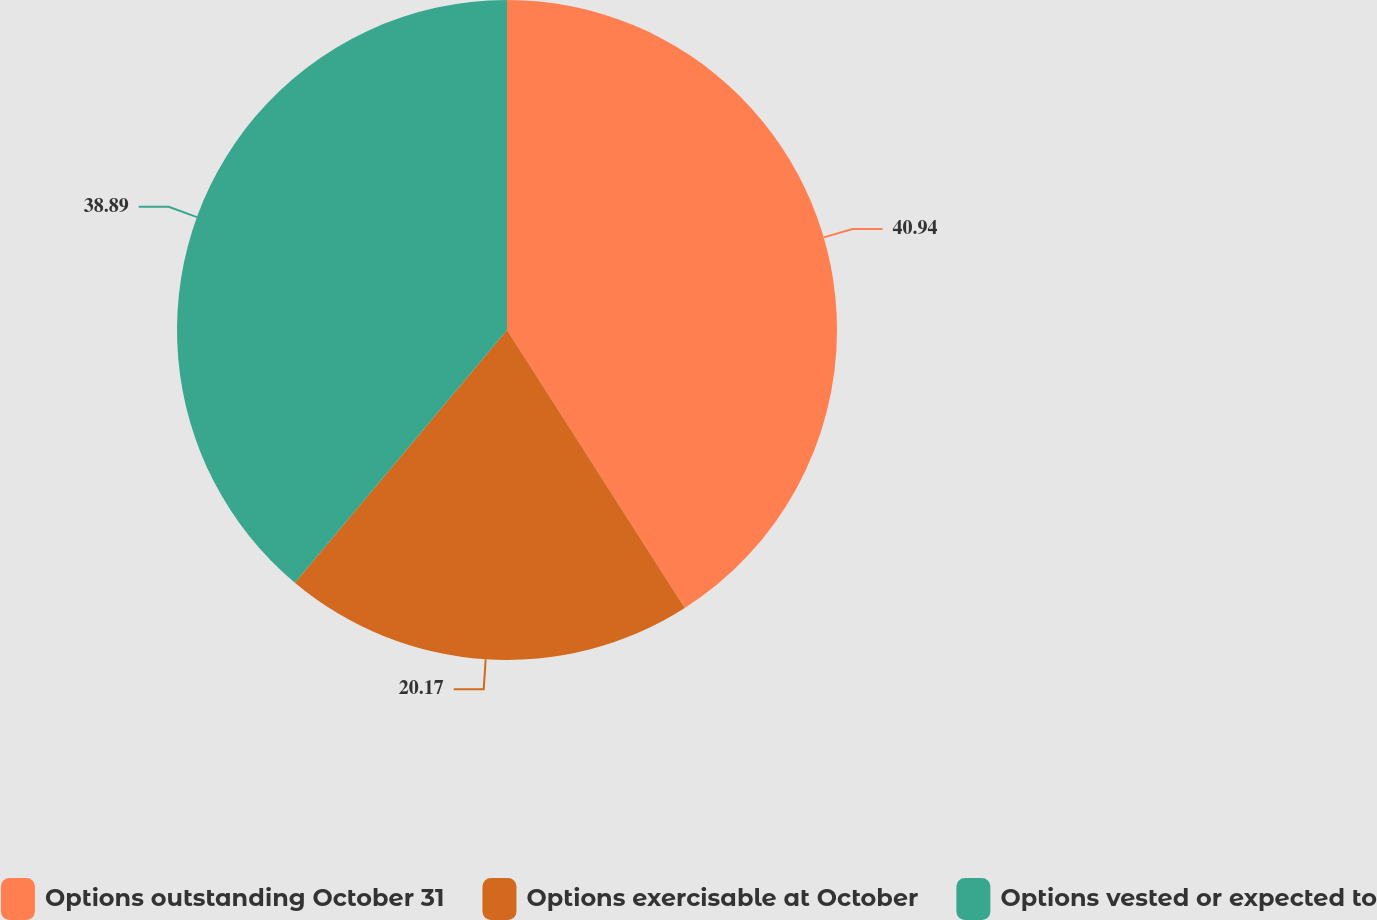Convert chart to OTSL. <chart><loc_0><loc_0><loc_500><loc_500><pie_chart><fcel>Options outstanding October 31<fcel>Options exercisable at October<fcel>Options vested or expected to<nl><fcel>40.95%<fcel>20.17%<fcel>38.89%<nl></chart> 